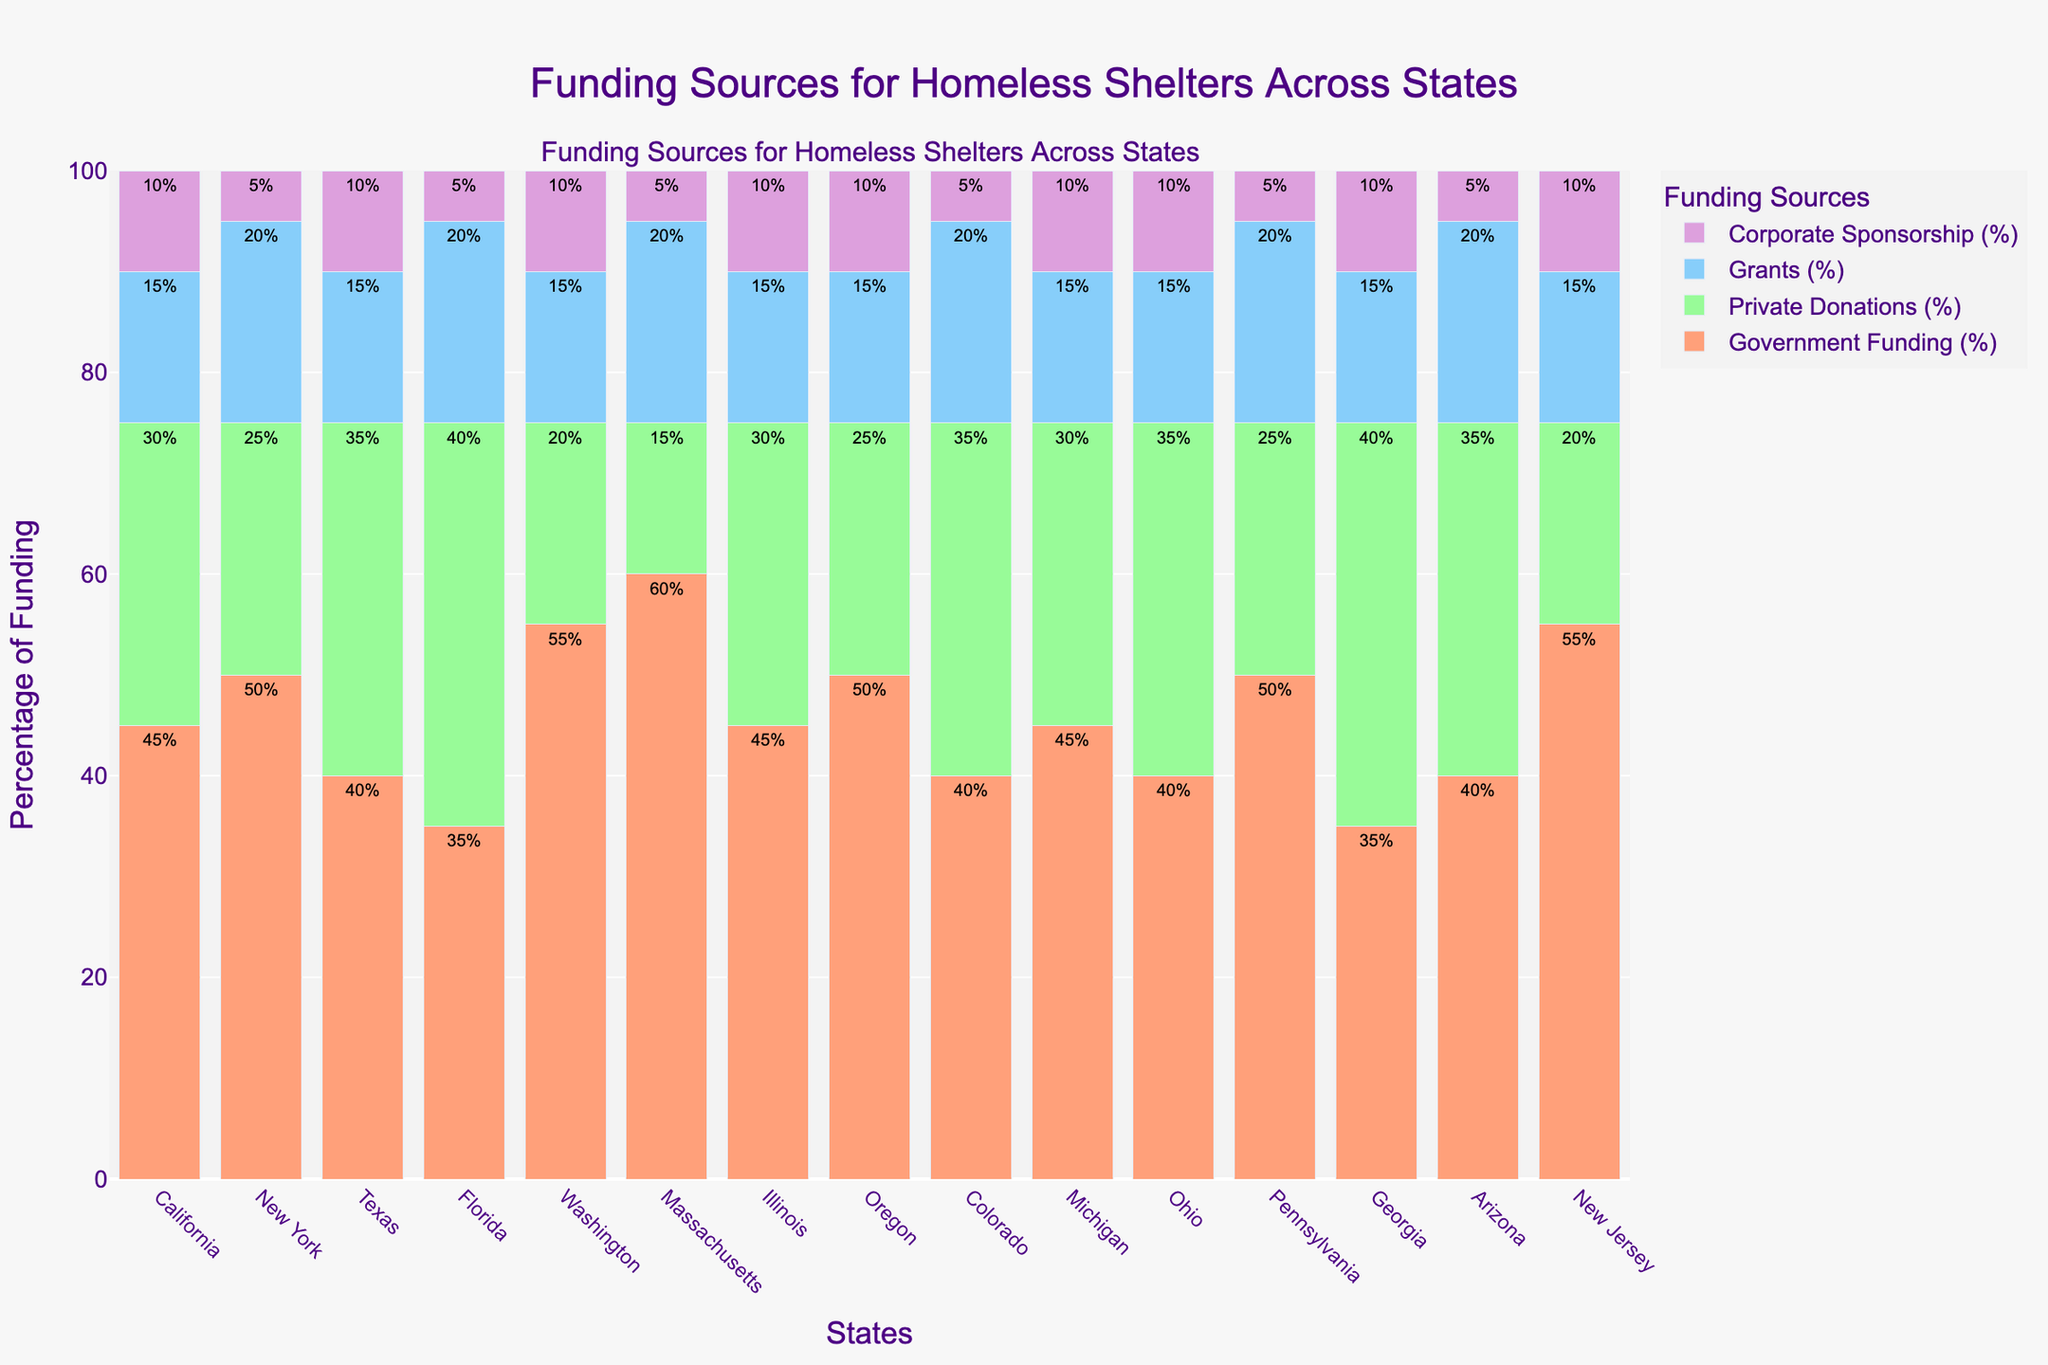Which state receives the highest percentage of government funding? To find the state with the highest percentage of government funding, look for the tallest bar corresponding to "Government Funding" in the bar chart. Massachusetts receives 60%, which is the highest.
Answer: Massachusetts Which two states have the same percentage of grants, and what is that percentage? Compare the heights of the bars corresponding to "Grants" for each state. California, Texas, Illinois, Washington, and Michigan all have bars of equal height, representing 15%. There are several pairs, so one pair (e.g., California and Texas) can be chosen.
Answer: California and Texas, 15% Which state relies most on corporate sponsorship? To determine the state that relies most on corporate sponsorship, look at the bar heights for "Corporate Sponsorship" and find the tallest one. California, Texas, Washington, Illinois, Oregon, Michigan, New Jersey, each at 10%, are the highest.
Answer: California, Texas, Washington, Illinois, Oregon, Michigan, New Jersey What is the combined percentage of private donations and corporate sponsorship for New York? Add the percentages of "Private Donations" and "Corporate Sponsorship" for New York. The values are 25% and 5%, respectively. So, 25% + 5% = 30%.
Answer: 30% Compare the percentage of private donations between Florida and Georgia. Which state has a higher percentage, and by how much? Look at the heights of the "Private Donations" bars for both Florida and Georgia. Florida has 40%, and Georgia also has 40%. The difference is 0% as they are equal.
Answer: Equal, 0% What is the difference between the highest and lowest percentage of government funding among all states? To find this, identify the highest and lowest percentages of government funding. Massachusetts has the highest at 60%, and Florida and Georgia have the lowest at 35%. The difference is 60% - 35% = 25%.
Answer: 25% Which states have an equal distribution of government funding and private donations? Compare the bars for "Government Funding" and "Private Donations" for each state. There are no states where these two percentages are equal.
Answer: None What is the total percentage of funding from grants and corporate sponsorship in Michigan? Add the percentages for "Grants" and "Corporate Sponsorship" in Michigan. The values are 15% and 10%, so 15% + 10% = 25%.
Answer: 25% Which states receive more than 50% of their funding from government sources? Look for states where the bar for "Government Funding" exceeds 50%. The states meeting this criterion are Massachusetts and Washington.
Answer: Massachusetts, Washington How does the percentage of private donations in Texas compare with that in Colorado? Compare the heights of the "Private Donations" bars for Texas (35%) and Colorado (35%). Both states have the same percentage.
Answer: Equal, 35% 